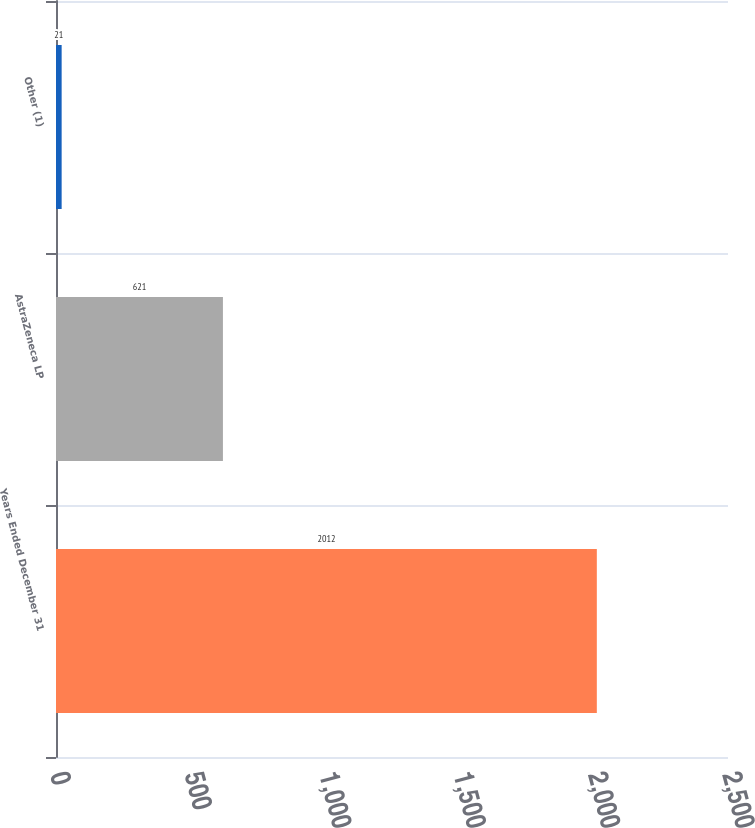Convert chart to OTSL. <chart><loc_0><loc_0><loc_500><loc_500><bar_chart><fcel>Years Ended December 31<fcel>AstraZeneca LP<fcel>Other (1)<nl><fcel>2012<fcel>621<fcel>21<nl></chart> 